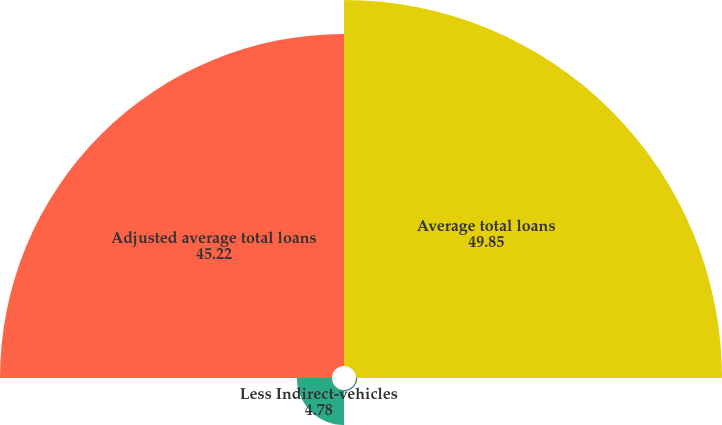Convert chart to OTSL. <chart><loc_0><loc_0><loc_500><loc_500><pie_chart><fcel>Average total loans<fcel>Less Balances of residential<fcel>Less Indirect-vehicles<fcel>Adjusted average total loans<nl><fcel>49.85%<fcel>0.15%<fcel>4.78%<fcel>45.22%<nl></chart> 